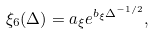<formula> <loc_0><loc_0><loc_500><loc_500>\xi _ { 6 } ( \Delta ) = a _ { \xi } e ^ { b _ { \xi } \Delta ^ { - 1 / 2 } } ,</formula> 